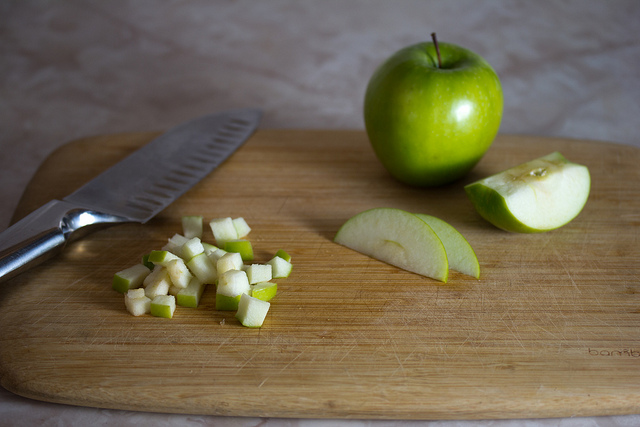Is there any indication that the apples are being cut into a specific shape or just randomly sliced? Yes, the apples in the image show deliberate shaping; there are neatly sliced wedges and finely diced pieces, suggesting careful preparation perhaps for a recipe requiring specific apple cuts for texture and presentation. 